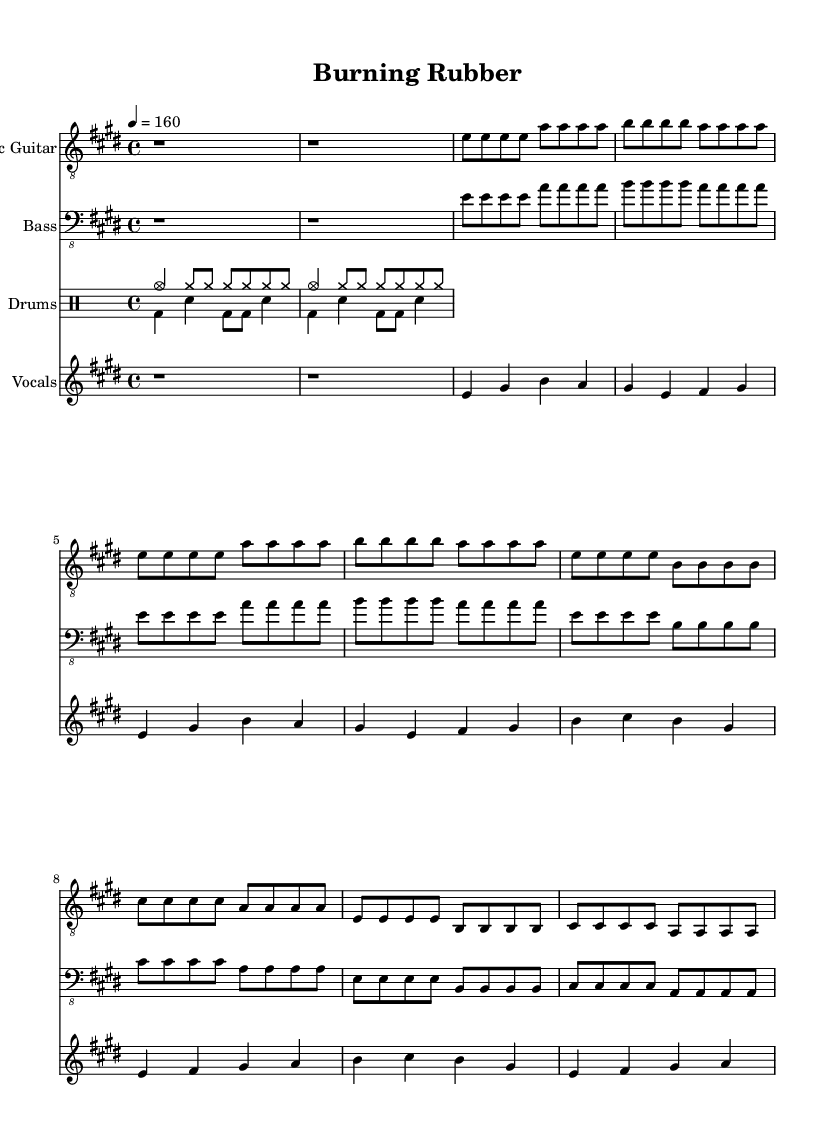What is the key signature of this music? The key signature is E major, which has four sharps: F#, C#, G#, and D#.
Answer: E major What is the time signature of this piece? The time signature is indicated as 4/4, which means there are four beats in each measure and the quarter note gets one beat.
Answer: 4/4 What is the tempo marking for this music? The tempo marking indicates a speed of 160 beats per minute, which contributes to the fast-paced feel typical of rock music.
Answer: 160 How many measures are in the verse section? The verse section consists of four measures, as indicated by the repetition of the verse musical phrases outlined in the sheet music.
Answer: 4 What instrument plays the melody? The melody is played by the vocals, as shown by the staff labeled "Vocals" in the sheet music.
Answer: Vocals What is the primary theme captured in the lyrics? The primary theme captured in the lyrics revolves around the excitement of driving and racing, emphasizing feelings of thrill, freedom, and speed.
Answer: Driving How many different instruments are included in this score? The score includes four different instruments: Electric Guitar, Bass, Drums, and Vocals, as indicated by the labeled staves in the sheet music.
Answer: 4 